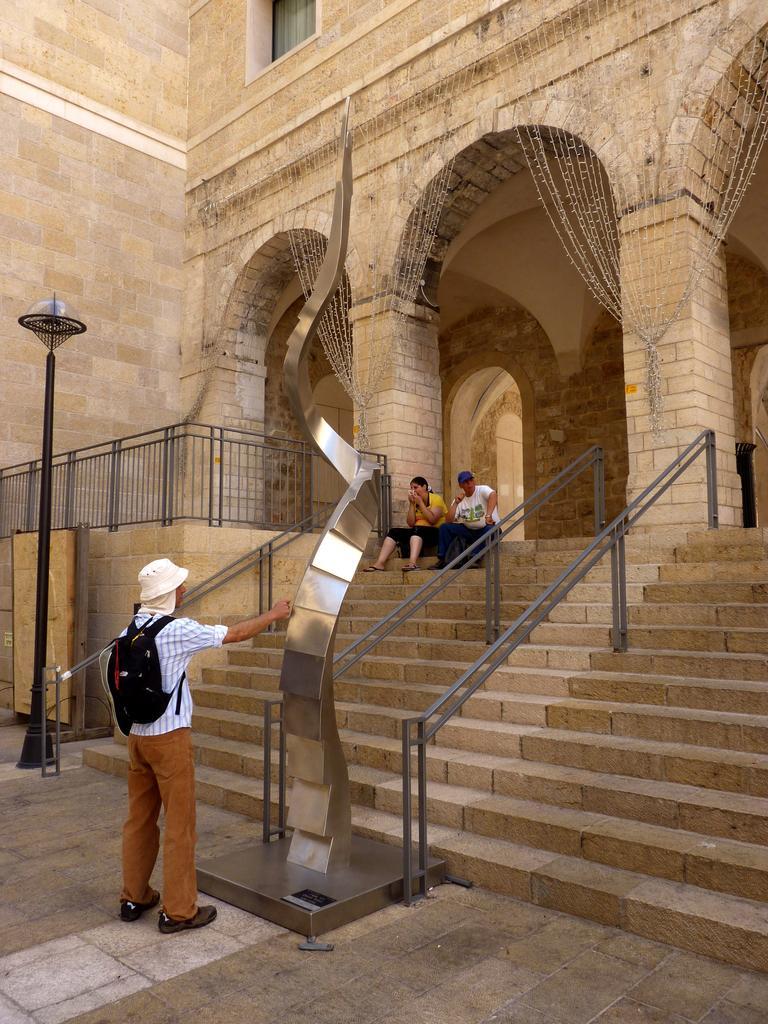Could you give a brief overview of what you see in this image? In this image there is a couple sat on the stairs of a building, in front of them there is a person standing and checking out a metal structure, beside the person there is a lamp post. 